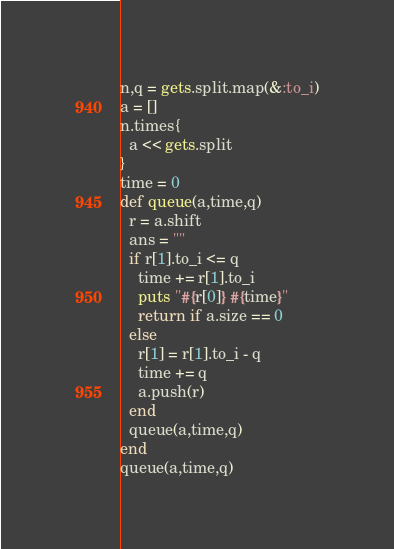<code> <loc_0><loc_0><loc_500><loc_500><_Ruby_>n,q = gets.split.map(&:to_i)
a = []
n.times{
  a << gets.split
}
time = 0
def queue(a,time,q)
  r = a.shift
  ans = ""
  if r[1].to_i <= q
    time += r[1].to_i
    puts "#{r[0]} #{time}"
    return if a.size == 0
  else
    r[1] = r[1].to_i - q
    time += q
    a.push(r)
  end
  queue(a,time,q)
end
queue(a,time,q)</code> 